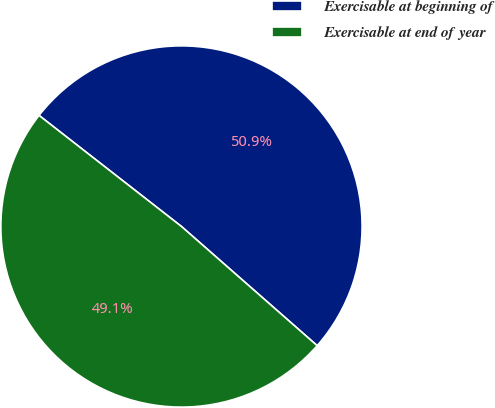Convert chart. <chart><loc_0><loc_0><loc_500><loc_500><pie_chart><fcel>Exercisable at beginning of<fcel>Exercisable at end of year<nl><fcel>50.93%<fcel>49.07%<nl></chart> 